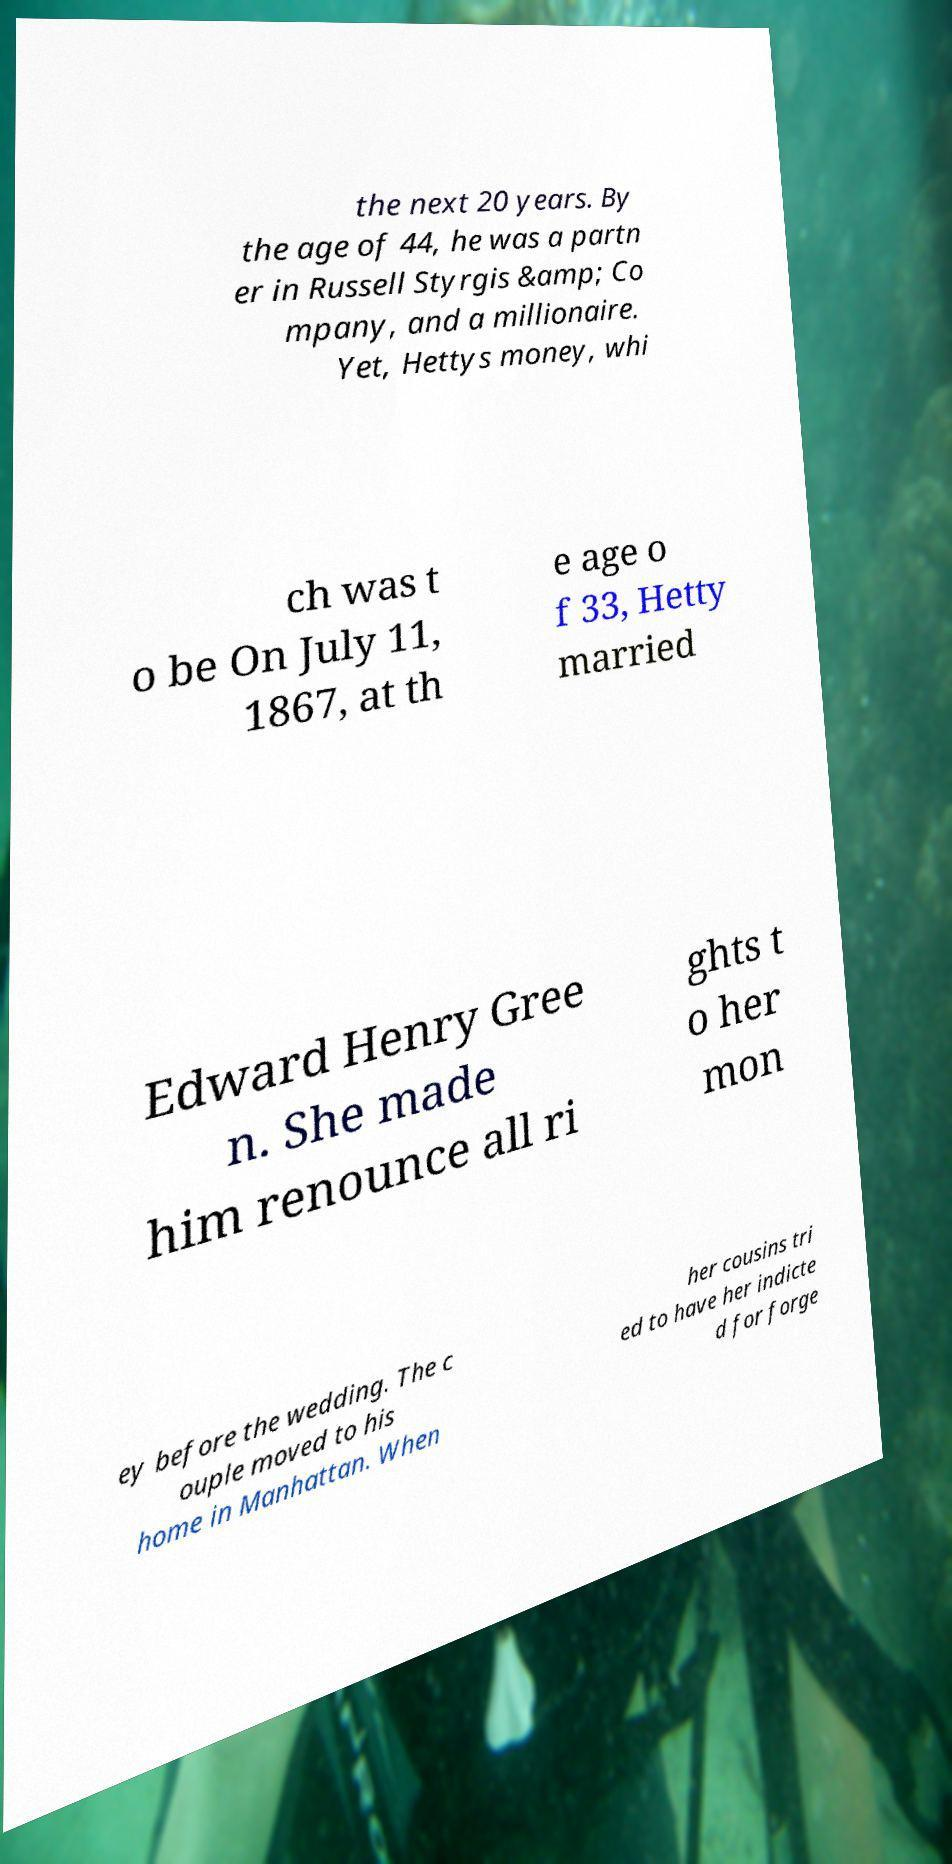Can you read and provide the text displayed in the image?This photo seems to have some interesting text. Can you extract and type it out for me? the next 20 years. By the age of 44, he was a partn er in Russell Styrgis &amp; Co mpany, and a millionaire. Yet, Hettys money, whi ch was t o be On July 11, 1867, at th e age o f 33, Hetty married Edward Henry Gree n. She made him renounce all ri ghts t o her mon ey before the wedding. The c ouple moved to his home in Manhattan. When her cousins tri ed to have her indicte d for forge 